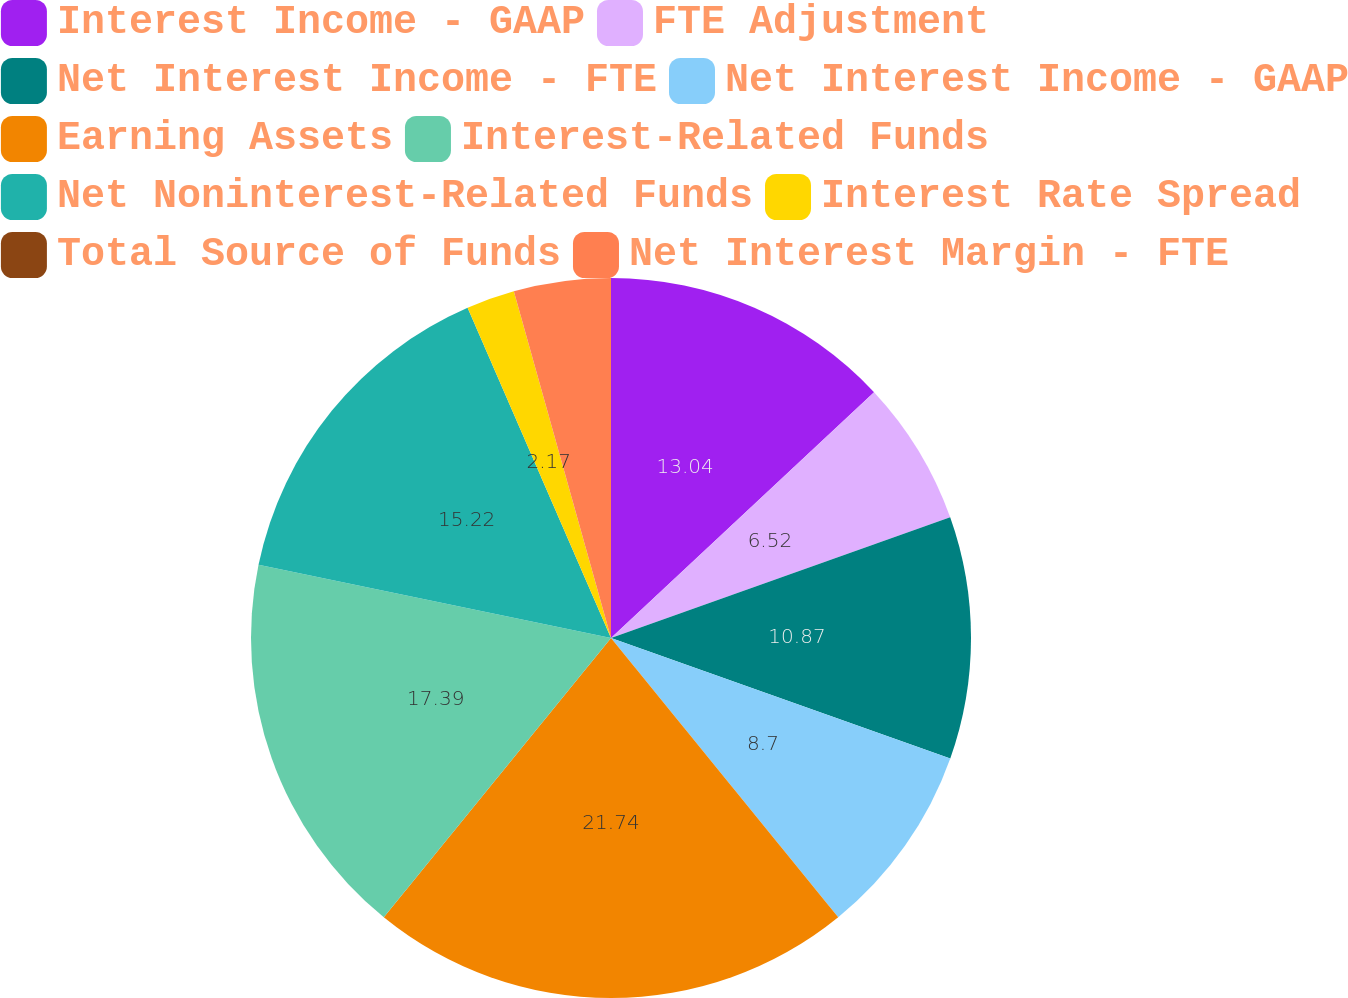Convert chart to OTSL. <chart><loc_0><loc_0><loc_500><loc_500><pie_chart><fcel>Interest Income - GAAP<fcel>FTE Adjustment<fcel>Net Interest Income - FTE<fcel>Net Interest Income - GAAP<fcel>Earning Assets<fcel>Interest-Related Funds<fcel>Net Noninterest-Related Funds<fcel>Interest Rate Spread<fcel>Total Source of Funds<fcel>Net Interest Margin - FTE<nl><fcel>13.04%<fcel>6.52%<fcel>10.87%<fcel>8.7%<fcel>21.74%<fcel>17.39%<fcel>15.22%<fcel>2.17%<fcel>0.0%<fcel>4.35%<nl></chart> 